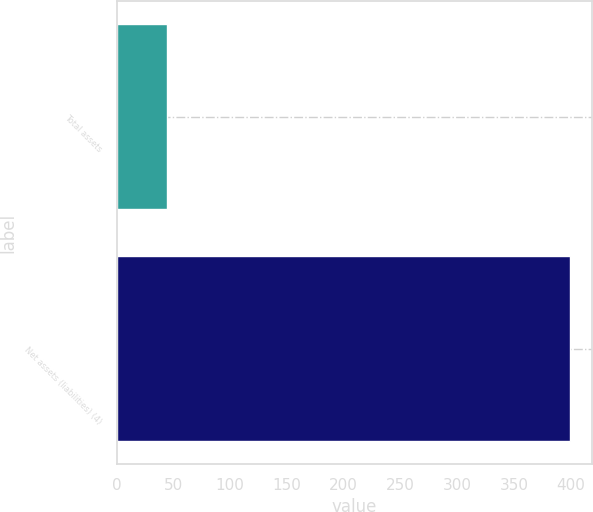<chart> <loc_0><loc_0><loc_500><loc_500><bar_chart><fcel>Total assets<fcel>Net assets (liabilities) (4)<nl><fcel>44<fcel>399<nl></chart> 